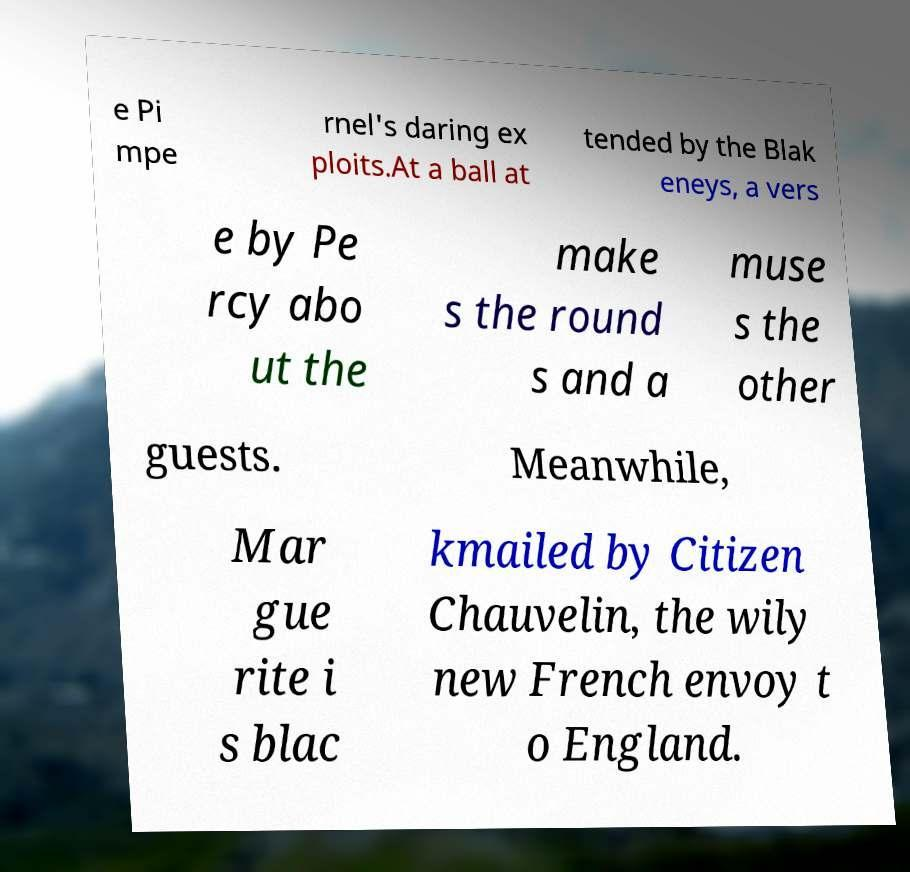There's text embedded in this image that I need extracted. Can you transcribe it verbatim? e Pi mpe rnel's daring ex ploits.At a ball at tended by the Blak eneys, a vers e by Pe rcy abo ut the make s the round s and a muse s the other guests. Meanwhile, Mar gue rite i s blac kmailed by Citizen Chauvelin, the wily new French envoy t o England. 